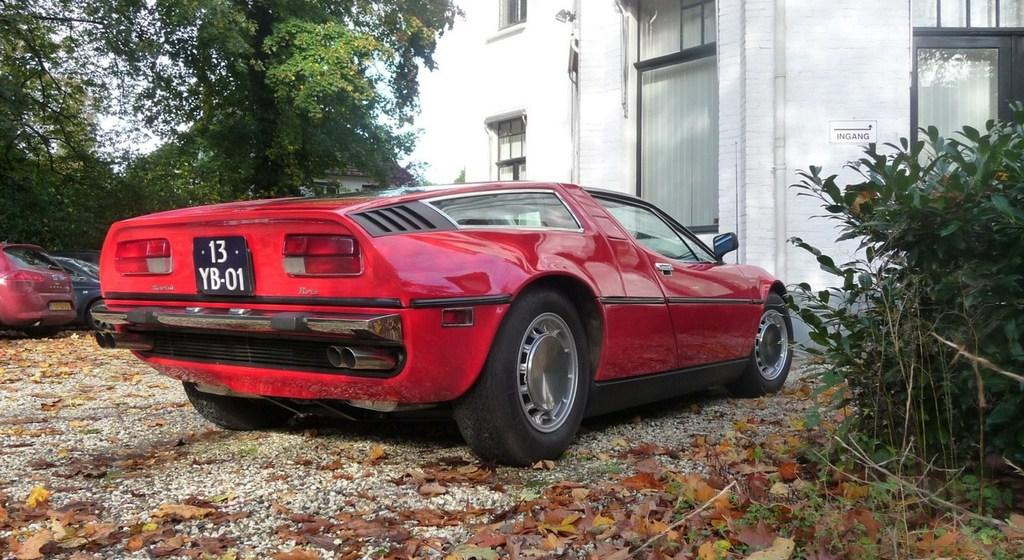What types of objects can be seen in the image? There are vehicles, trees, a building, a house, plants, dried leaves, and stones in the image. Can you describe the natural elements in the image? There are trees, plants, and dried leaves in the image. What type of structure is present in the image? There is a building and a house in the image. What is visible in the sky in the image? The sky is visible in the image. Can you see any goldfish swimming in the image? There are no goldfish present in the image. What type of knot is being used to secure the house in the image? There is no knot present in the image, as knots are not used to secure houses. 